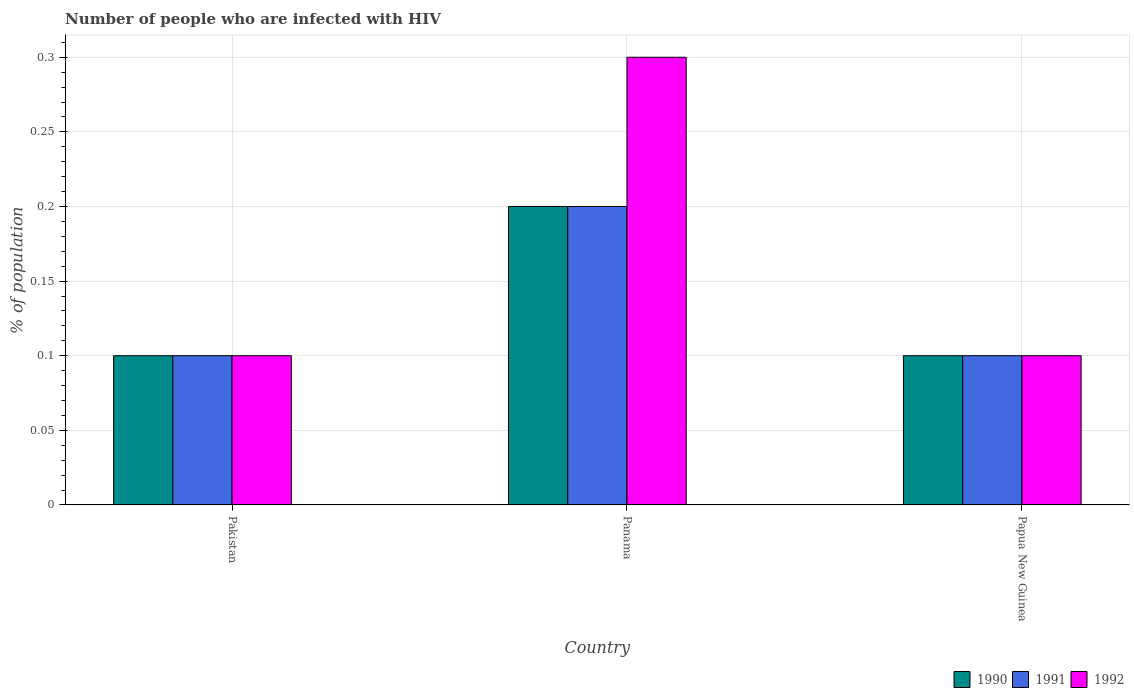Are the number of bars on each tick of the X-axis equal?
Offer a very short reply. Yes. How many bars are there on the 2nd tick from the right?
Ensure brevity in your answer.  3. What is the label of the 2nd group of bars from the left?
Give a very brief answer. Panama. What is the percentage of HIV infected population in in 1990 in Papua New Guinea?
Your response must be concise. 0.1. Across all countries, what is the minimum percentage of HIV infected population in in 1991?
Give a very brief answer. 0.1. In which country was the percentage of HIV infected population in in 1991 maximum?
Offer a very short reply. Panama. What is the difference between the percentage of HIV infected population in in 1991 in Panama and that in Papua New Guinea?
Give a very brief answer. 0.1. What is the difference between the percentage of HIV infected population in in 1992 in Pakistan and the percentage of HIV infected population in in 1990 in Papua New Guinea?
Your answer should be very brief. 0. What is the average percentage of HIV infected population in in 1992 per country?
Give a very brief answer. 0.17. What is the difference between the percentage of HIV infected population in of/in 1990 and percentage of HIV infected population in of/in 1992 in Pakistan?
Ensure brevity in your answer.  0. What is the ratio of the percentage of HIV infected population in in 1990 in Pakistan to that in Panama?
Ensure brevity in your answer.  0.5. Is the percentage of HIV infected population in in 1992 in Pakistan less than that in Papua New Guinea?
Make the answer very short. No. Is the difference between the percentage of HIV infected population in in 1990 in Panama and Papua New Guinea greater than the difference between the percentage of HIV infected population in in 1992 in Panama and Papua New Guinea?
Make the answer very short. No. What is the difference between the highest and the second highest percentage of HIV infected population in in 1991?
Keep it short and to the point. 0.1. What is the difference between the highest and the lowest percentage of HIV infected population in in 1992?
Provide a succinct answer. 0.2. In how many countries, is the percentage of HIV infected population in in 1990 greater than the average percentage of HIV infected population in in 1990 taken over all countries?
Your response must be concise. 1. Is the sum of the percentage of HIV infected population in in 1991 in Pakistan and Panama greater than the maximum percentage of HIV infected population in in 1992 across all countries?
Give a very brief answer. Yes. What does the 3rd bar from the left in Papua New Guinea represents?
Provide a succinct answer. 1992. Are all the bars in the graph horizontal?
Your response must be concise. No. What is the difference between two consecutive major ticks on the Y-axis?
Provide a short and direct response. 0.05. Are the values on the major ticks of Y-axis written in scientific E-notation?
Provide a succinct answer. No. Does the graph contain grids?
Your answer should be very brief. Yes. How are the legend labels stacked?
Offer a terse response. Horizontal. What is the title of the graph?
Provide a succinct answer. Number of people who are infected with HIV. What is the label or title of the Y-axis?
Give a very brief answer. % of population. What is the % of population of 1992 in Pakistan?
Provide a short and direct response. 0.1. What is the % of population in 1991 in Panama?
Provide a short and direct response. 0.2. What is the % of population of 1992 in Panama?
Your response must be concise. 0.3. What is the % of population of 1990 in Papua New Guinea?
Provide a short and direct response. 0.1. What is the % of population in 1991 in Papua New Guinea?
Provide a short and direct response. 0.1. What is the % of population in 1992 in Papua New Guinea?
Your response must be concise. 0.1. Across all countries, what is the minimum % of population of 1990?
Make the answer very short. 0.1. Across all countries, what is the minimum % of population in 1991?
Keep it short and to the point. 0.1. Across all countries, what is the minimum % of population of 1992?
Offer a very short reply. 0.1. What is the total % of population in 1990 in the graph?
Provide a short and direct response. 0.4. What is the total % of population in 1991 in the graph?
Give a very brief answer. 0.4. What is the total % of population in 1992 in the graph?
Your response must be concise. 0.5. What is the difference between the % of population in 1992 in Pakistan and that in Papua New Guinea?
Make the answer very short. 0. What is the difference between the % of population of 1990 in Pakistan and the % of population of 1991 in Panama?
Give a very brief answer. -0.1. What is the difference between the % of population in 1990 in Pakistan and the % of population in 1992 in Panama?
Provide a short and direct response. -0.2. What is the difference between the % of population of 1990 in Pakistan and the % of population of 1991 in Papua New Guinea?
Give a very brief answer. 0. What is the difference between the % of population of 1991 in Pakistan and the % of population of 1992 in Papua New Guinea?
Offer a terse response. 0. What is the difference between the % of population of 1990 in Panama and the % of population of 1992 in Papua New Guinea?
Your response must be concise. 0.1. What is the average % of population in 1990 per country?
Offer a terse response. 0.13. What is the average % of population of 1991 per country?
Your answer should be compact. 0.13. What is the average % of population of 1992 per country?
Ensure brevity in your answer.  0.17. What is the difference between the % of population in 1990 and % of population in 1992 in Pakistan?
Provide a short and direct response. 0. What is the difference between the % of population of 1990 and % of population of 1992 in Panama?
Your answer should be very brief. -0.1. What is the difference between the % of population in 1991 and % of population in 1992 in Panama?
Offer a terse response. -0.1. What is the difference between the % of population of 1991 and % of population of 1992 in Papua New Guinea?
Provide a succinct answer. 0. What is the ratio of the % of population in 1990 in Pakistan to that in Panama?
Provide a short and direct response. 0.5. What is the ratio of the % of population of 1990 in Pakistan to that in Papua New Guinea?
Your answer should be very brief. 1. What is the ratio of the % of population in 1991 in Pakistan to that in Papua New Guinea?
Provide a short and direct response. 1. What is the difference between the highest and the second highest % of population of 1991?
Your response must be concise. 0.1. What is the difference between the highest and the lowest % of population in 1992?
Your answer should be very brief. 0.2. 